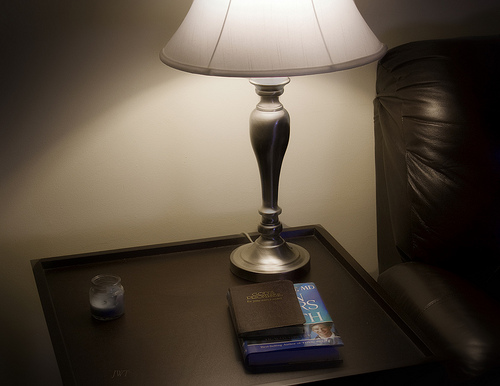<image>
Is the candle behind the book? No. The candle is not behind the book. From this viewpoint, the candle appears to be positioned elsewhere in the scene. 